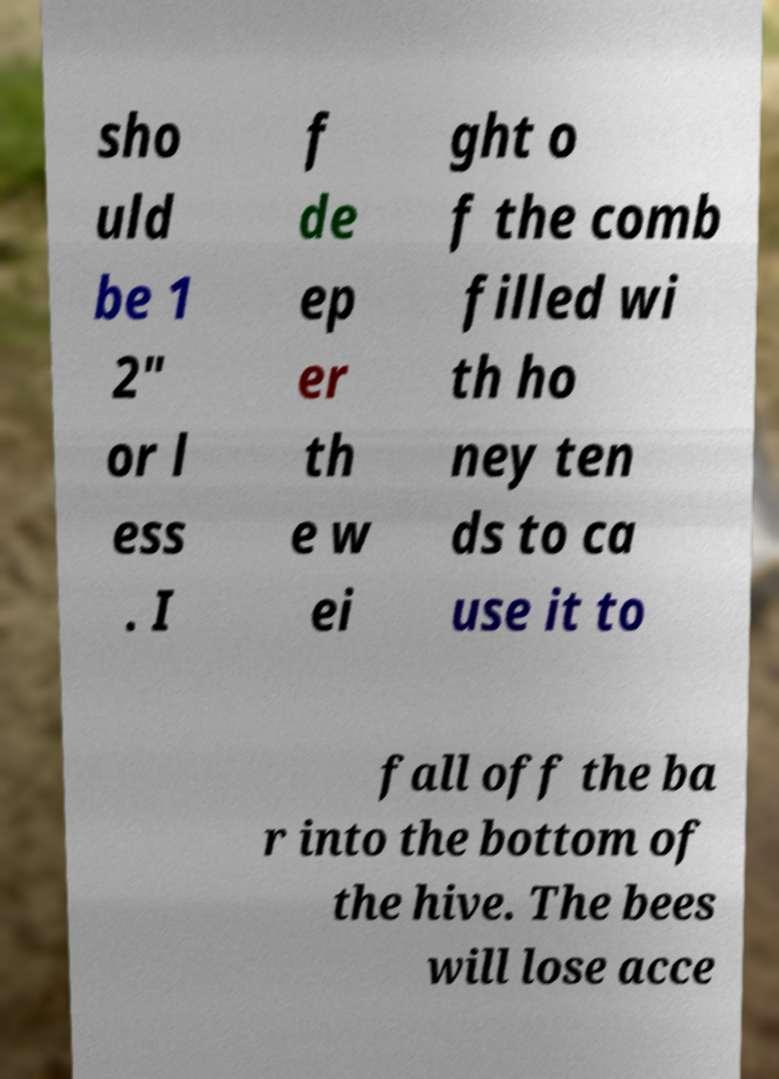For documentation purposes, I need the text within this image transcribed. Could you provide that? sho uld be 1 2" or l ess . I f de ep er th e w ei ght o f the comb filled wi th ho ney ten ds to ca use it to fall off the ba r into the bottom of the hive. The bees will lose acce 